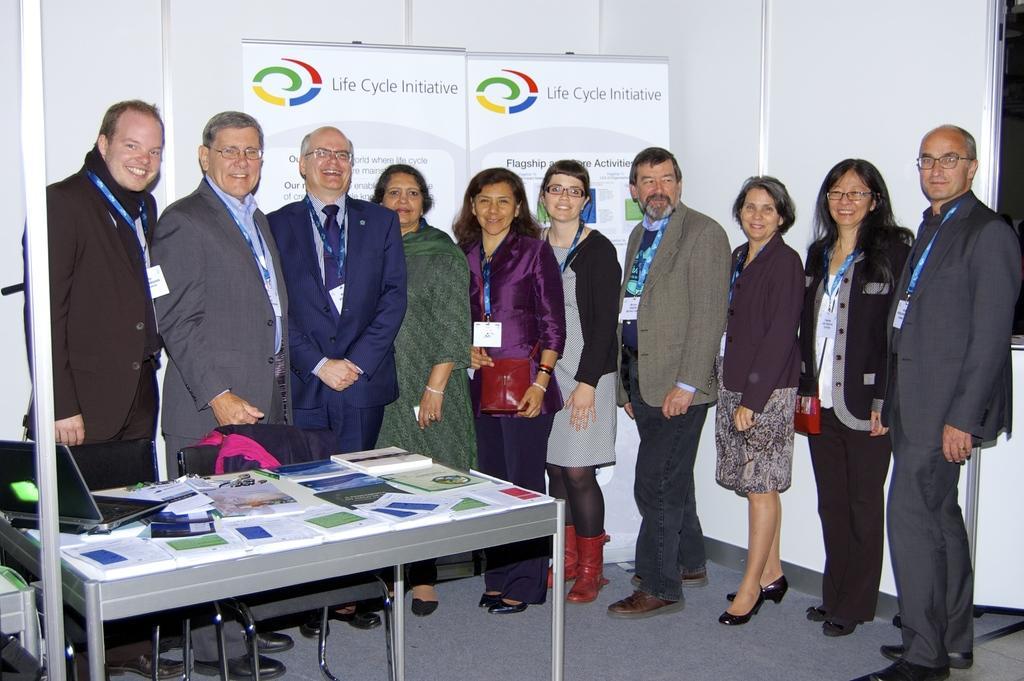Could you give a brief overview of what you see in this image? There are many people in the image. They all are dressed up neatly and all are smiling. All of them wore tags and identity cards. There is a table and chairs in front of them. On the table there is a laptop, papers and brochures. In the background there is banner with a text Life Cycle Initiative and a logo beside it.  